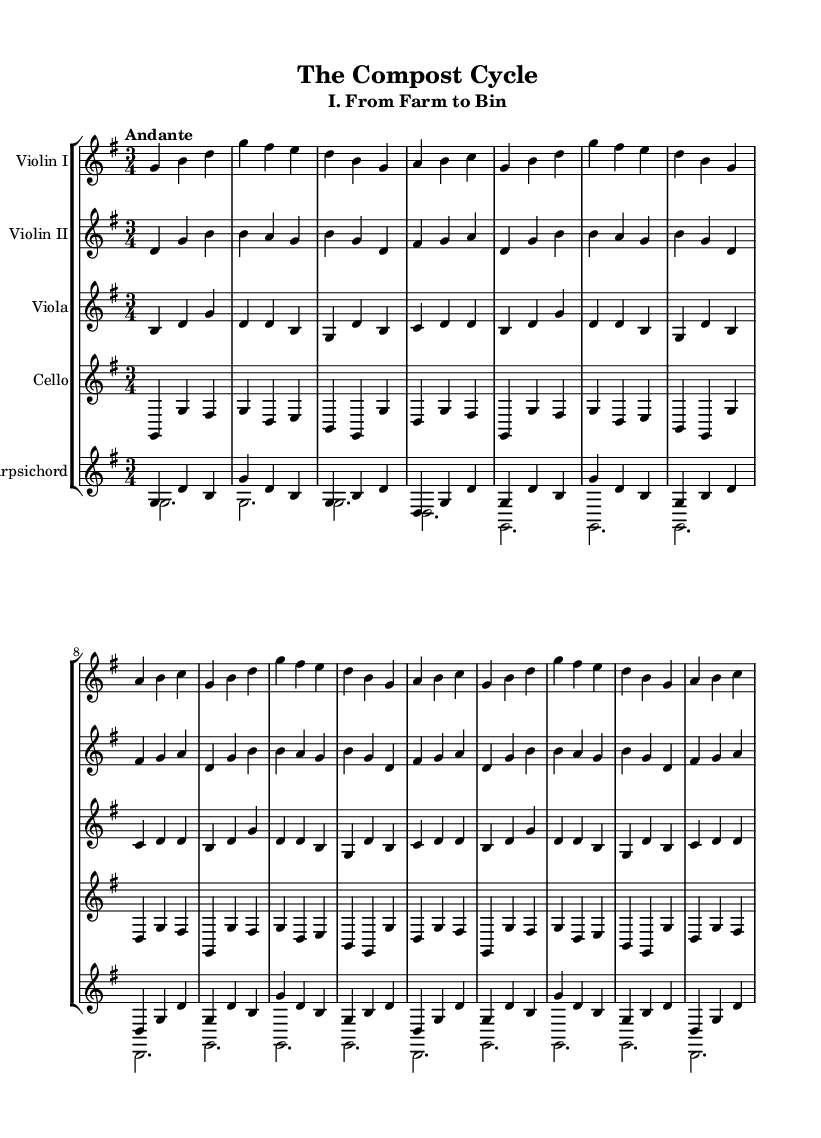What is the key signature of this music? The key signature is indicated at the beginning of the sheet music. It shows one sharp (F#), which corresponds to G major.
Answer: G major What is the time signature of this music? The time signature is displayed at the beginning of the music. It shows three beats per measure, represented as 3/4.
Answer: 3/4 What is the tempo marking of this piece? The tempo marking is written in Italian above the staff, indicating the desired speed of the piece, which is "Andante," meaning a moderate walking pace.
Answer: Andante How many instruments are featured in this chamber music suite? The music is arranged for a total of five instruments, including two violins, viola, cello, and a harpsichord.
Answer: Five What is the first section title of the suite? The title of the first section of the suite is explicitly mentioned under the main title, labeled as "I. From Farm to Bin."
Answer: I. From Farm to Bin How many times is the first musical phrase repeated? The first musical phrase, as notated in the parts, is marked to be repeated three times, suggested by the use of "repeat unfold 3."
Answer: Three times What characteristic of the music suggests it's typical of the Baroque period? The presence of a continuo instrument, in this case, the harpsichord, is a common feature of Baroque chamber music, which typically includes both melodic instruments and a keyboard accompanying unit.
Answer: Harpsichord 